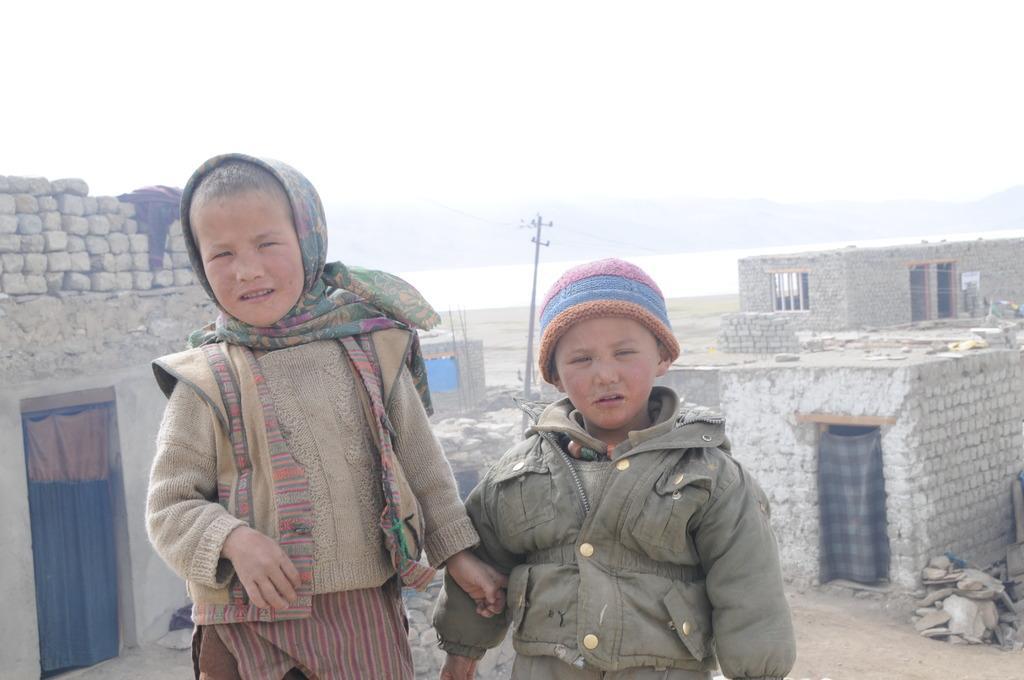Could you give a brief overview of what you see in this image? This picture shows two kids and we see one of them wore cap on the head and another one wore cloth on the head and both of them wore coats and we see couple of houses and a electrical pole and a cloudy sky. 